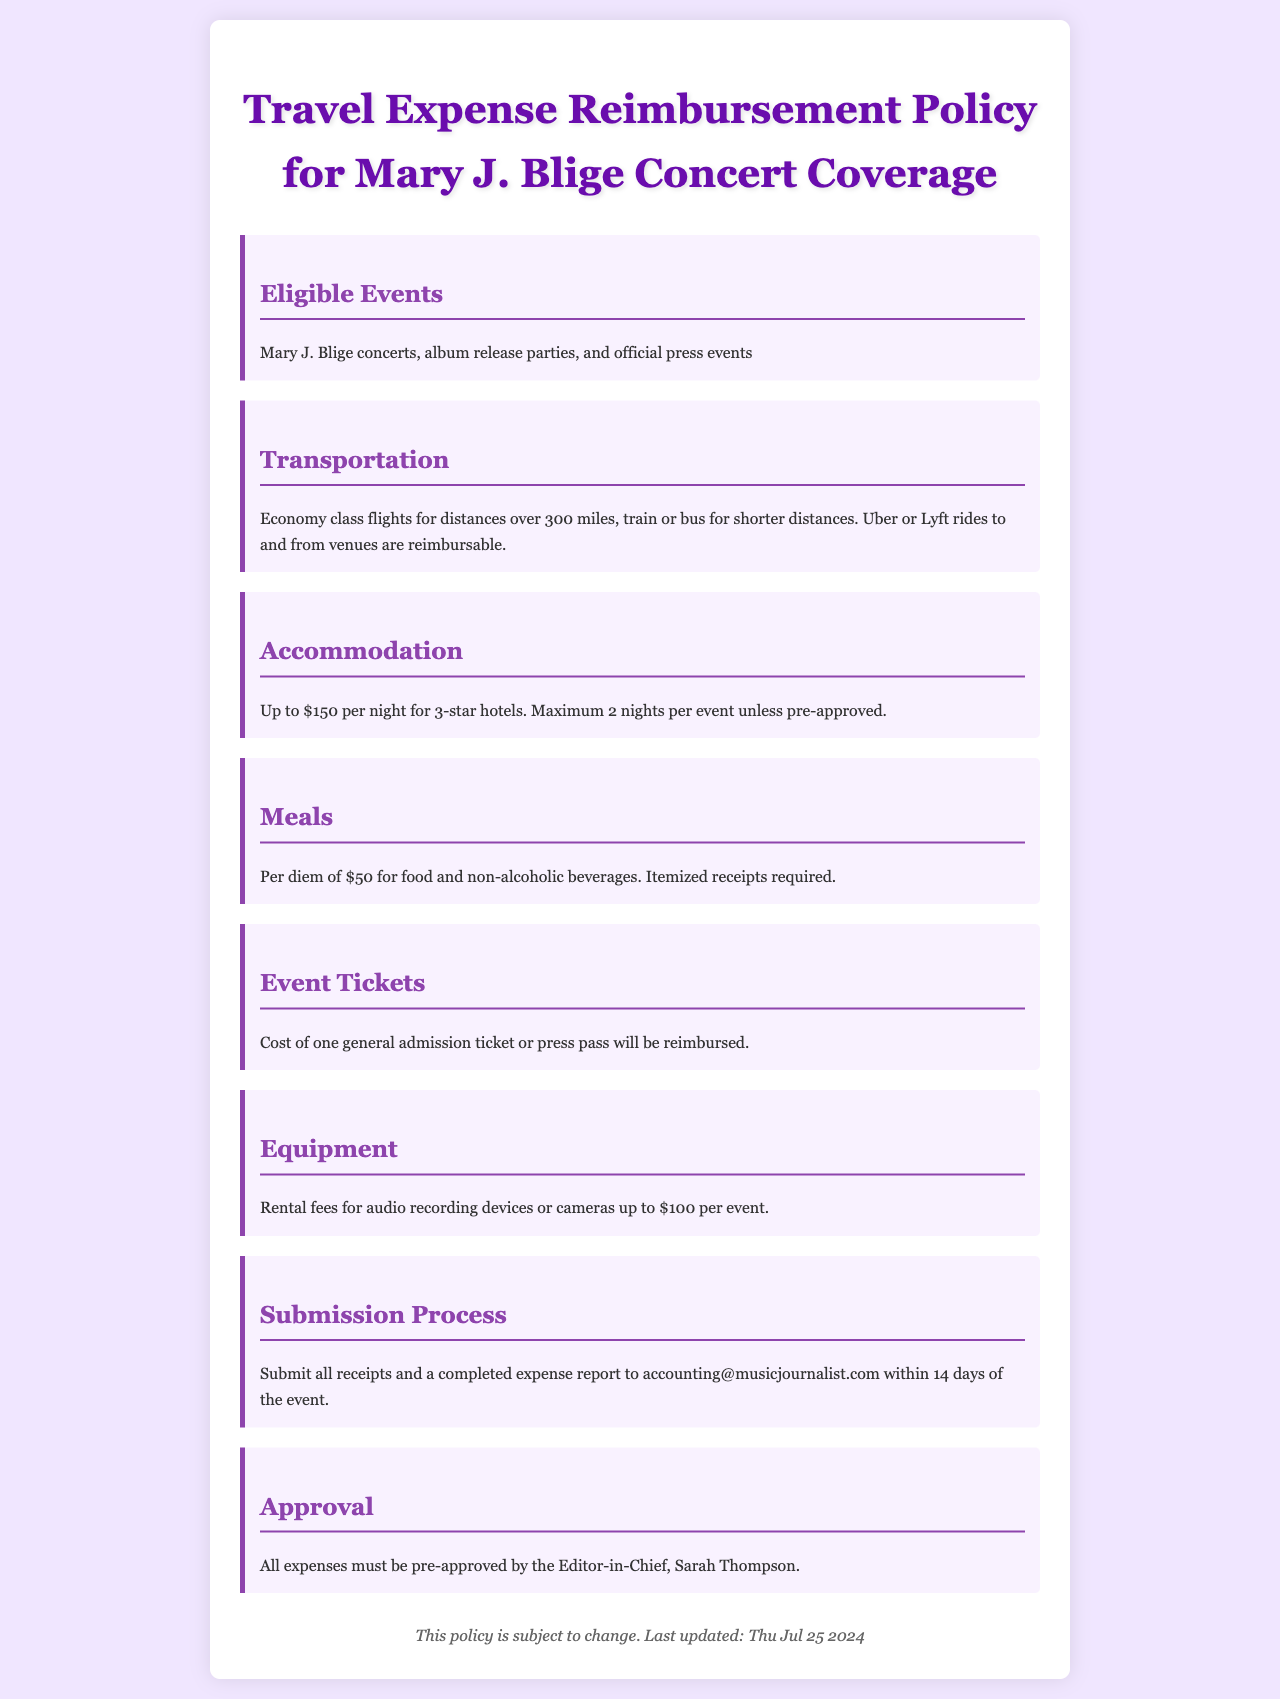What events are eligible for reimbursement? The document specifies that eligible events include Mary J. Blige concerts, album release parties, and official press events.
Answer: Mary J. Blige concerts, album release parties, and official press events What is the maximum reimbursement for accommodation? The document states that the maximum reimbursement for accommodation is up to $150 per night for 3-star hotels.
Answer: $150 How many nights are covered per event? The policy indicates a maximum of 2 nights per event unless pre-approved.
Answer: 2 nights What is the per diem amount for meals? The document mentions a per diem of $50 for food and non-alcoholic beverages.
Answer: $50 Who must approve all expenses? According to the document, all expenses must be pre-approved by the Editor-in-Chief, Sarah Thompson.
Answer: Sarah Thompson What type of transportation is reimbursable for distances over 300 miles? The policy specifies that economy class flights are reimbursable for distances over 300 miles.
Answer: Economy class flights What is the maximum rental fee for equipment? The document allows rental fees for audio recording devices or cameras up to $100 per event.
Answer: $100 What is required to be submitted for reimbursement? The submission process in the document requires all receipts and a completed expense report.
Answer: All receipts and a completed expense report How long do you have to submit the expense report after the event? The document states that expense reports must be submitted within 14 days of the event.
Answer: 14 days 